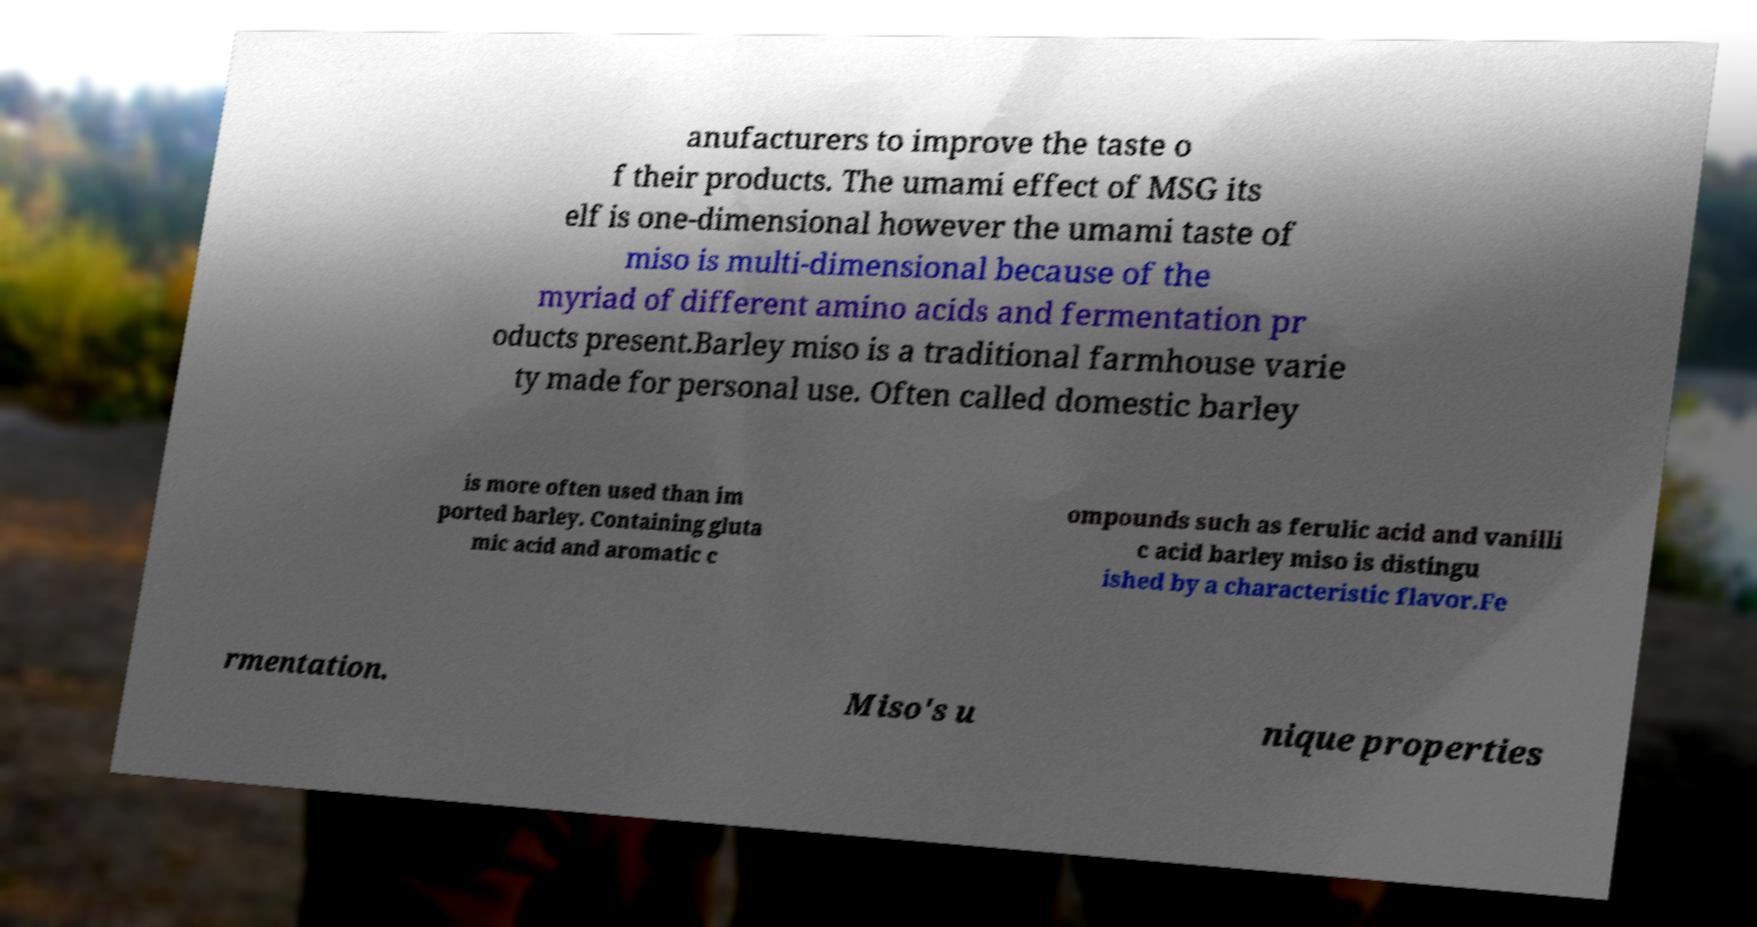Please identify and transcribe the text found in this image. anufacturers to improve the taste o f their products. The umami effect of MSG its elf is one-dimensional however the umami taste of miso is multi-dimensional because of the myriad of different amino acids and fermentation pr oducts present.Barley miso is a traditional farmhouse varie ty made for personal use. Often called domestic barley is more often used than im ported barley. Containing gluta mic acid and aromatic c ompounds such as ferulic acid and vanilli c acid barley miso is distingu ished by a characteristic flavor.Fe rmentation. Miso's u nique properties 